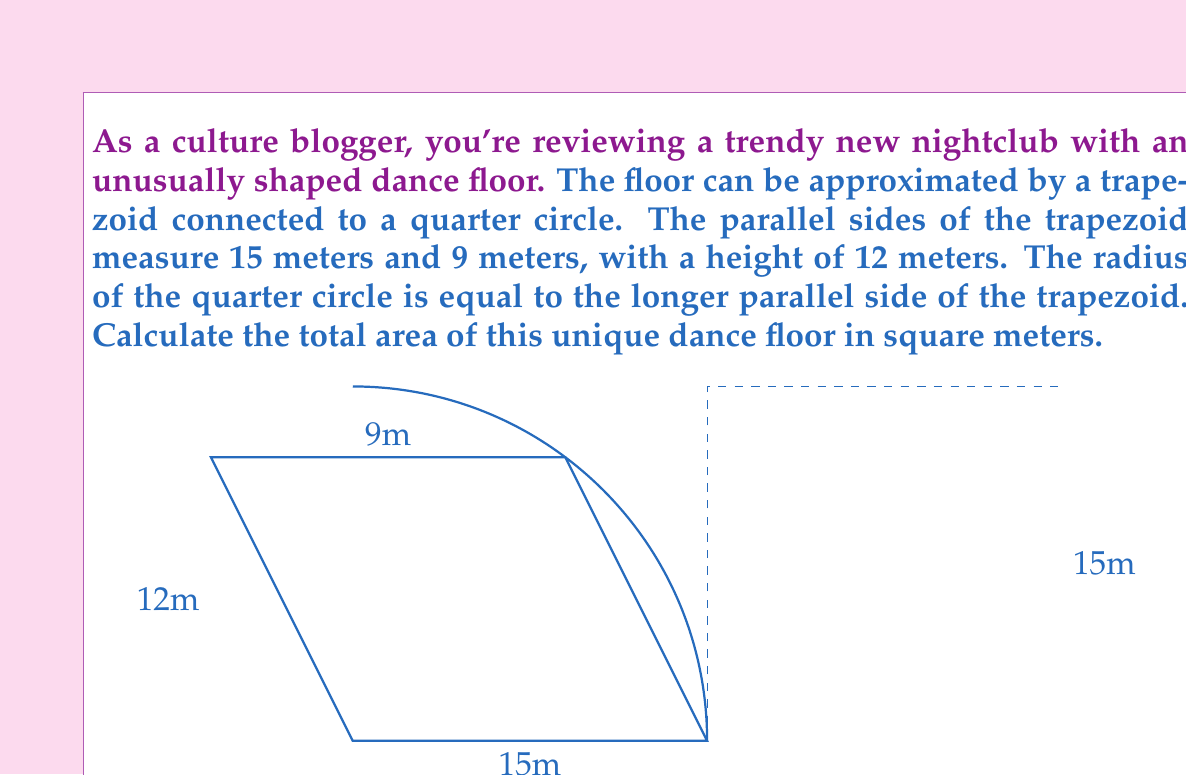What is the answer to this math problem? To solve this problem, we need to calculate the areas of the trapezoid and the quarter circle separately, then add them together.

1. Area of the trapezoid:
   The formula for the area of a trapezoid is:
   $$A_{trapezoid} = \frac{1}{2}(b_1 + b_2)h$$
   where $b_1$ and $b_2$ are the parallel sides and $h$ is the height.

   $$A_{trapezoid} = \frac{1}{2}(15 + 9) \times 12 = \frac{1}{2} \times 24 \times 12 = 144 \text{ m}^2$$

2. Area of the quarter circle:
   The radius of the quarter circle is 15 meters (equal to the longer side of the trapezoid).
   The formula for the area of a circle is $\pi r^2$, so for a quarter circle, it's:
   $$A_{quarter circle} = \frac{1}{4}\pi r^2$$

   $$A_{quarter circle} = \frac{1}{4}\pi \times 15^2 = \frac{225\pi}{4} \approx 176.71 \text{ m}^2$$

3. Total area:
   $$A_{total} = A_{trapezoid} + A_{quarter circle}$$
   $$A_{total} = 144 + \frac{225\pi}{4} \approx 320.71 \text{ m}^2$$
Answer: The total area of the dance floor is $144 + \frac{225\pi}{4} \approx 320.71 \text{ m}^2$. 